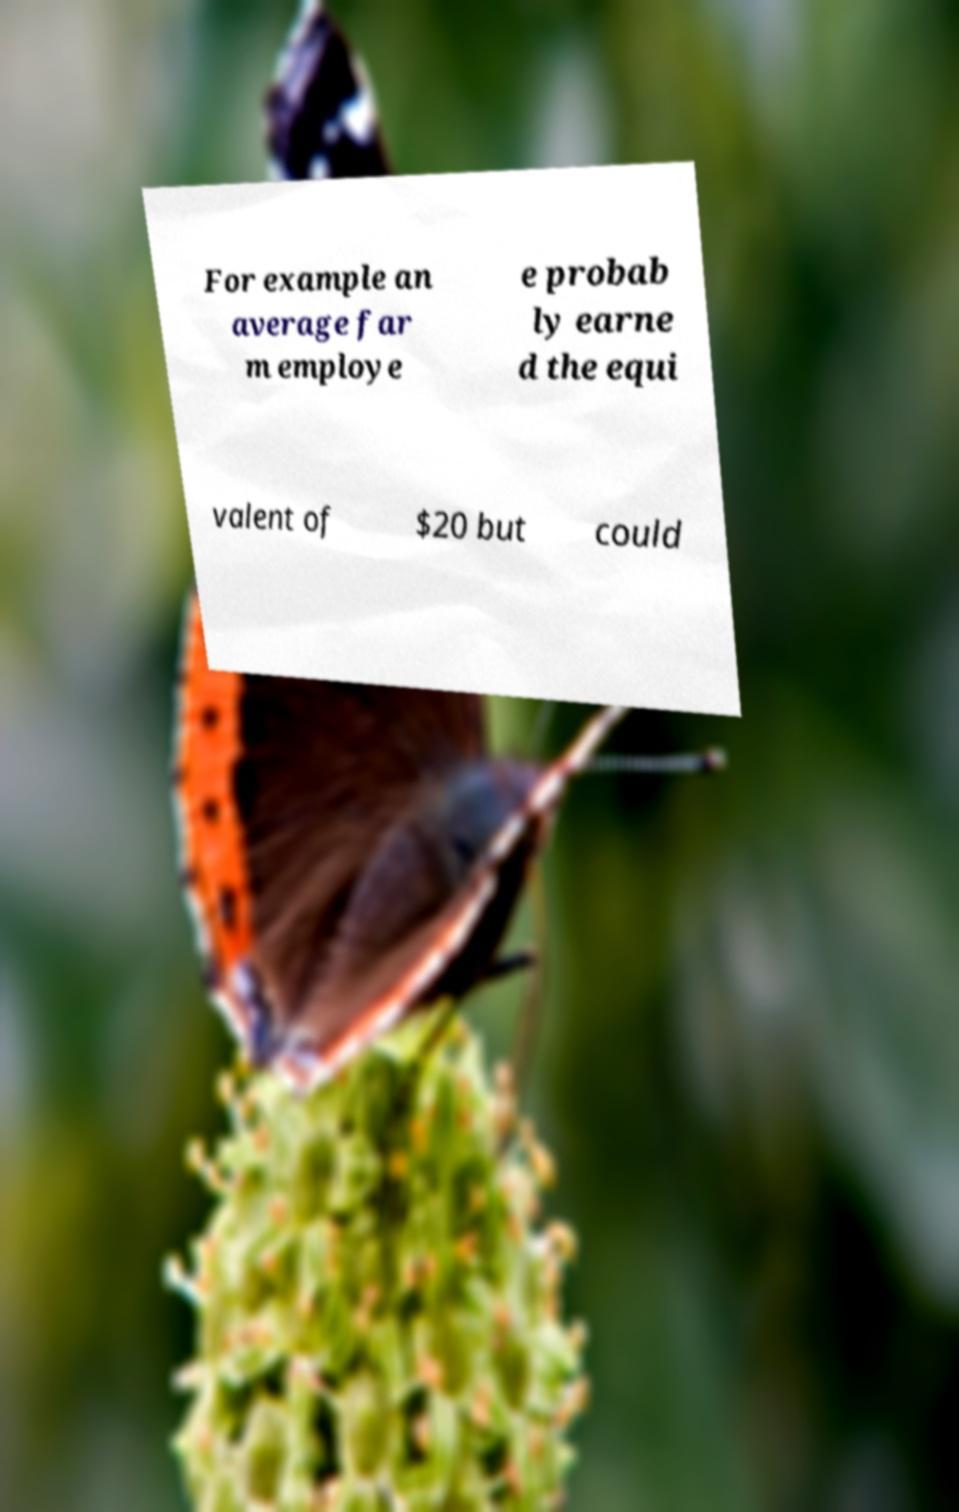Please identify and transcribe the text found in this image. For example an average far m employe e probab ly earne d the equi valent of $20 but could 